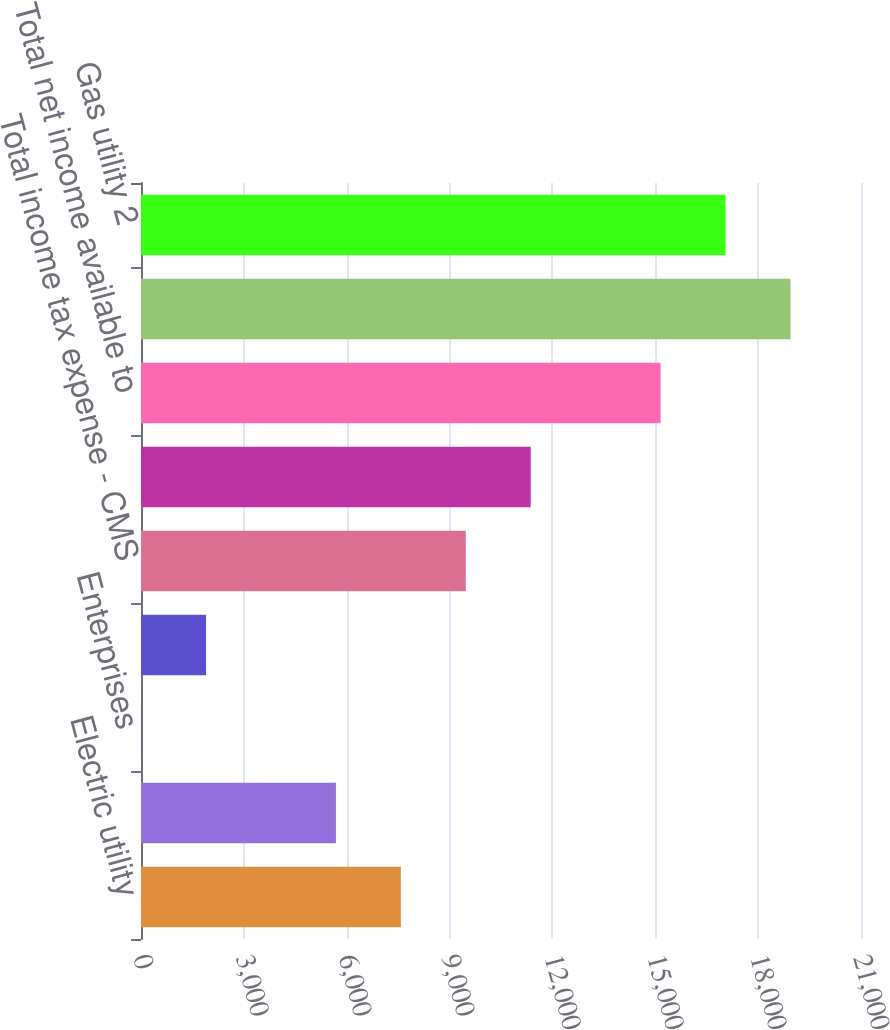Convert chart to OTSL. <chart><loc_0><loc_0><loc_500><loc_500><bar_chart><fcel>Electric utility<fcel>Gas utility<fcel>Enterprises<fcel>Other reconciling items<fcel>Total income tax expense - CMS<fcel>Total income tax expense -<fcel>Total net income available to<fcel>Electric utility 2<fcel>Gas utility 2<nl><fcel>7579<fcel>5685<fcel>3<fcel>1897<fcel>9473<fcel>11367<fcel>15155<fcel>18943<fcel>17049<nl></chart> 